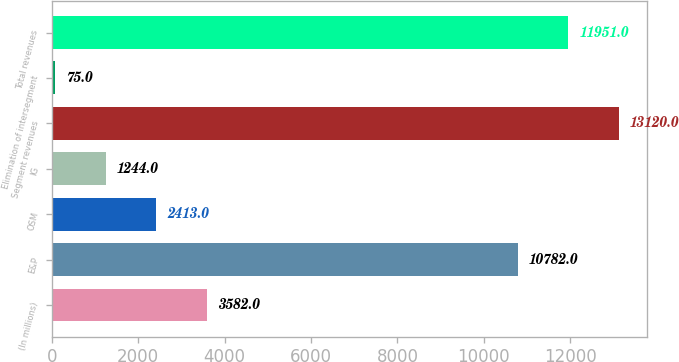<chart> <loc_0><loc_0><loc_500><loc_500><bar_chart><fcel>(In millions)<fcel>E&P<fcel>OSM<fcel>IG<fcel>Segment revenues<fcel>Elimination of intersegment<fcel>Total revenues<nl><fcel>3582<fcel>10782<fcel>2413<fcel>1244<fcel>13120<fcel>75<fcel>11951<nl></chart> 